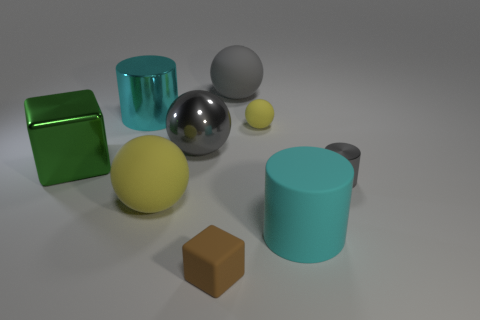Can you identify the different colors present in the geometric shapes? Certainly! In the image, I can identify several colors: there is a green cube, a yellow sphere, and a small brown cube. Additionally, there is a reflective silver sphere, a gray smaller sphere, and two cylinders—one matte teal and the other transparent teal. 